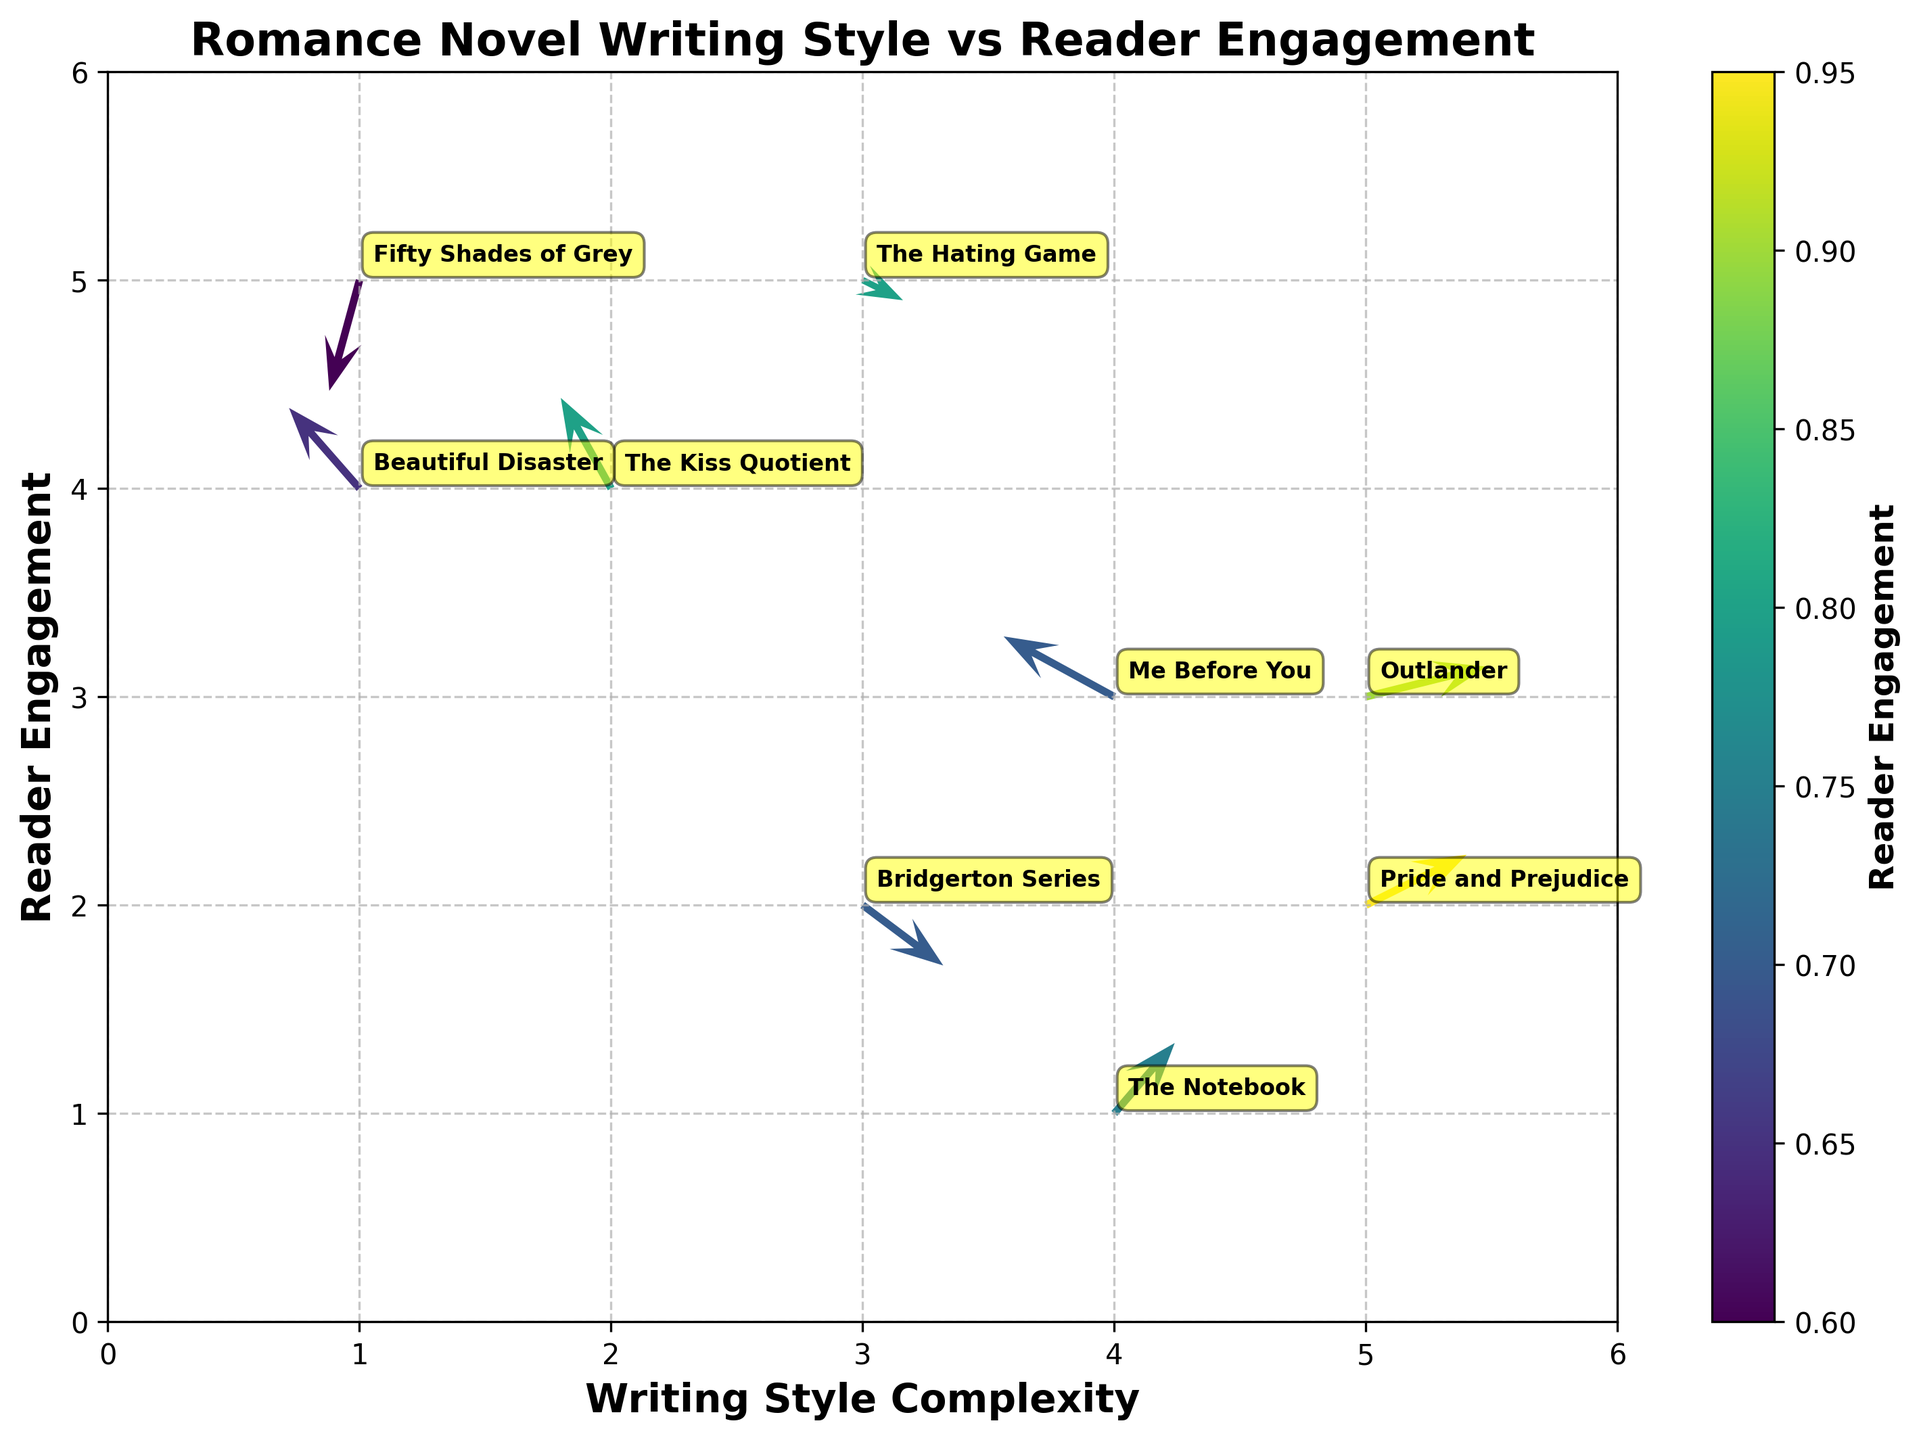What's the title of the plot? The title is located at the top of the plot. It usually describes what the graph represents.
Answer: "Romance Novel Writing Style vs Reader Engagement" What are the labels on the x-axis and y-axis? The labels on the x and y-axes usually denote what each axis represents. They are written alongside the axes.
Answer: The x-axis is labeled "Writing Style Complexity" and the y-axis is labeled "Reader Engagement" Which book has the highest reader engagement based on the color gradient? The color gradient, as indicated by the color bar, shows reader engagement levels. Look for the brightest or most intense color.
Answer: "Pride and Prejudice" What direction is indicated for "The Kiss Quotient"? Examine the arrow corresponding to "The Kiss Quotient" on the plot. The direction can be observed from the base of the arrow to the head.
Answer: The direction is up and to the right, indicating positive x and y directions How does the reader engagement of "Me Before You" compare to "The Notebook"? Compare the color intensity for both points. Darker or more intense colors indicate higher engagement.
Answer: "The Notebook" has slightly higher reader engagement than "Me Before You" Which book shows a decrease in reader engagement despite high writing style complexity? Examine the arrows pointing downward (negative y direction). Check the starting points for higher complexity.
Answer: "Fifty Shades of Grey" Calculate the change in reader engagement for "Beautiful Disaster". The change in reader engagement corresponds to the length and direction of the arrow's vertical component (v value).
Answer: Increase by 0.8 (v value) Are there more arrows pointing upward or downward, and what might that indicate? Count the arrows with a positive vertical component (upward) and compare with those with a negative vertical component (downward).
Answer: More arrows are pointing upward, indicating a general trend of increasing reader engagement Which book demonstrates the least writing style complexity? Look at the position on the x-axis; the furthest left point has the lowest complexity.
Answer: "Fifty Shades of Grey" What can you infer about the engagement levels relative to writing complexity from this plot? Examine if there's a visible trend in the plot regarding the direction and length of arrows against the x and y positions.
Answer: In general, higher writing complexity shows positive engagement changes, but there are exceptions 